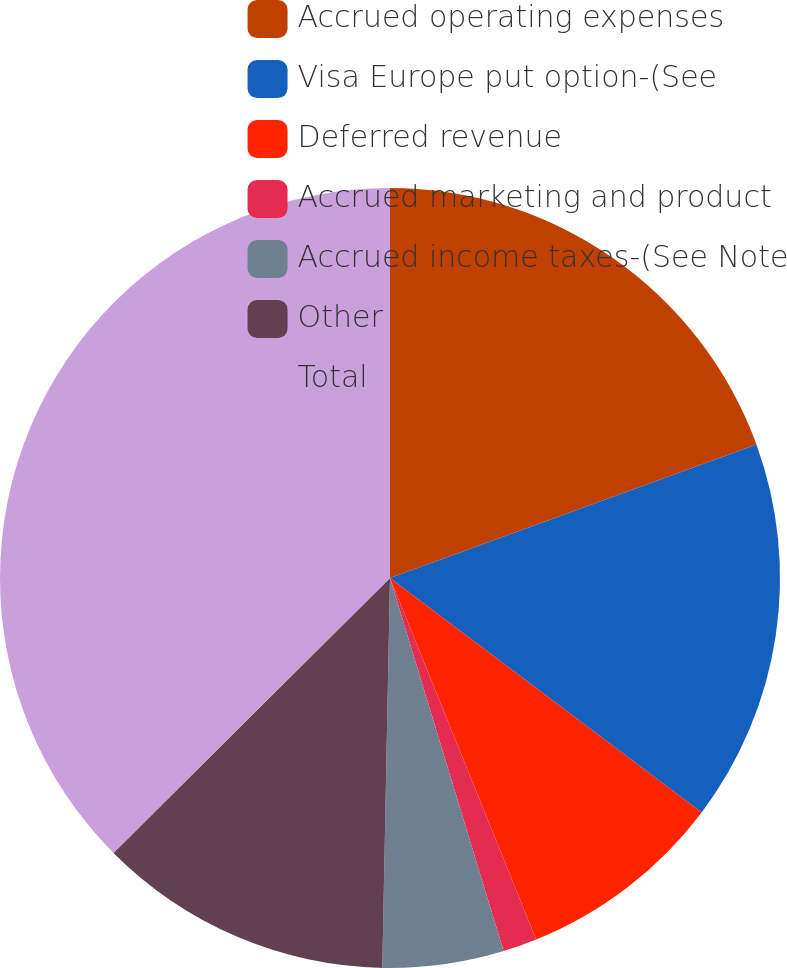Convert chart. <chart><loc_0><loc_0><loc_500><loc_500><pie_chart><fcel>Accrued operating expenses<fcel>Visa Europe put option-(See<fcel>Deferred revenue<fcel>Accrued marketing and product<fcel>Accrued income taxes-(See Note<fcel>Other<fcel>Total<nl><fcel>19.44%<fcel>15.83%<fcel>8.62%<fcel>1.41%<fcel>5.02%<fcel>12.23%<fcel>37.46%<nl></chart> 